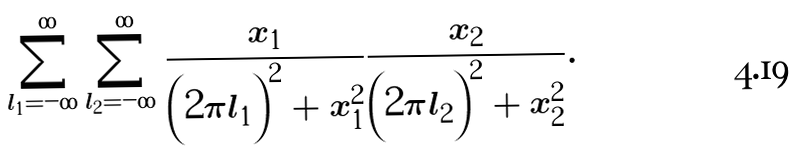Convert formula to latex. <formula><loc_0><loc_0><loc_500><loc_500>\sum _ { l _ { 1 } = - \infty } ^ { \infty } \sum _ { l _ { 2 } = - \infty } ^ { \infty } \frac { x _ { 1 } } { \left ( 2 \pi l _ { 1 } \right ) ^ { 2 } + x _ { 1 } ^ { 2 } } \frac { x _ { 2 } } { \left ( 2 \pi l _ { 2 } \right ) ^ { 2 } + x _ { 2 } ^ { 2 } } .</formula> 